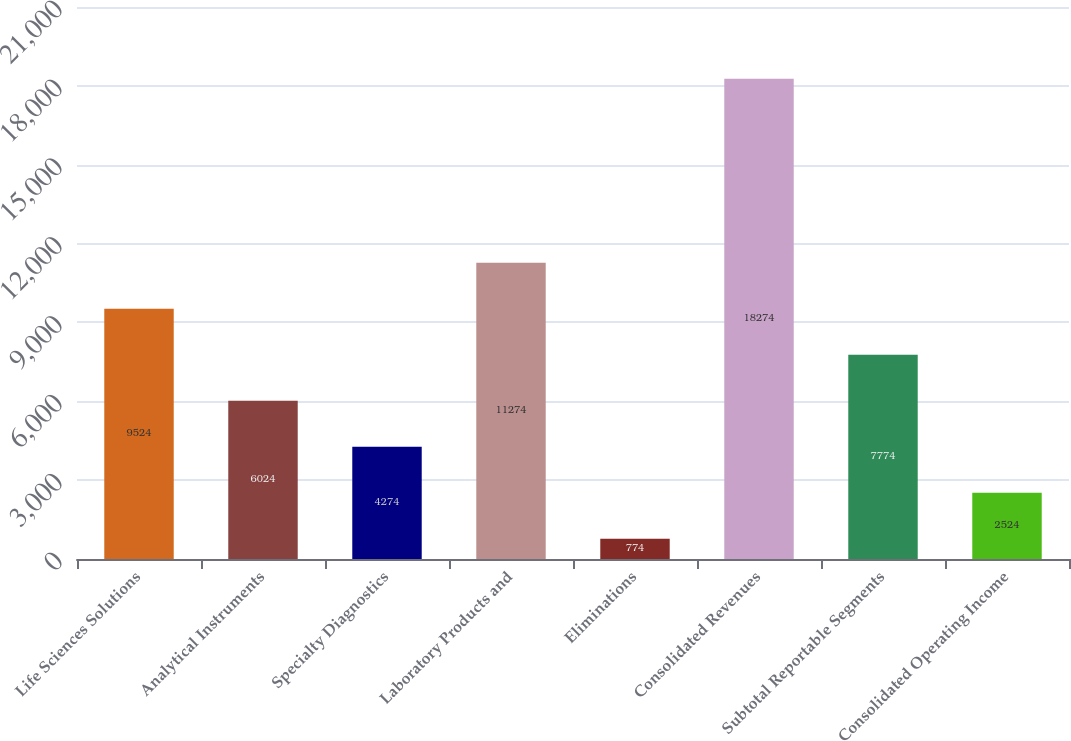<chart> <loc_0><loc_0><loc_500><loc_500><bar_chart><fcel>Life Sciences Solutions<fcel>Analytical Instruments<fcel>Specialty Diagnostics<fcel>Laboratory Products and<fcel>Eliminations<fcel>Consolidated Revenues<fcel>Subtotal Reportable Segments<fcel>Consolidated Operating Income<nl><fcel>9524<fcel>6024<fcel>4274<fcel>11274<fcel>774<fcel>18274<fcel>7774<fcel>2524<nl></chart> 